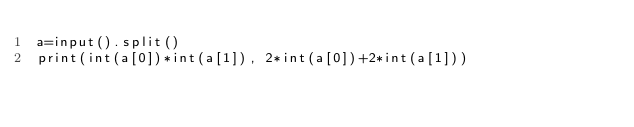Convert code to text. <code><loc_0><loc_0><loc_500><loc_500><_Python_>a=input().split()
print(int(a[0])*int(a[1]), 2*int(a[0])+2*int(a[1]))

</code> 